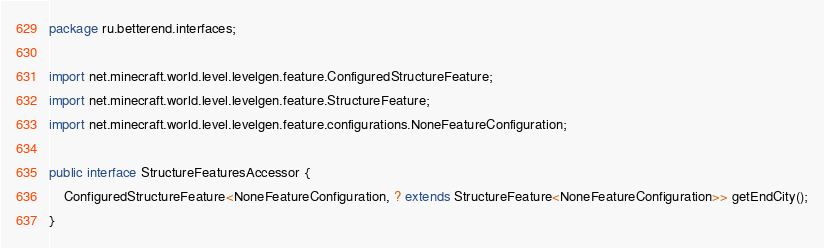Convert code to text. <code><loc_0><loc_0><loc_500><loc_500><_Java_>package ru.betterend.interfaces;

import net.minecraft.world.level.levelgen.feature.ConfiguredStructureFeature;
import net.minecraft.world.level.levelgen.feature.StructureFeature;
import net.minecraft.world.level.levelgen.feature.configurations.NoneFeatureConfiguration;

public interface StructureFeaturesAccessor {
	ConfiguredStructureFeature<NoneFeatureConfiguration, ? extends StructureFeature<NoneFeatureConfiguration>> getEndCity();
}
</code> 